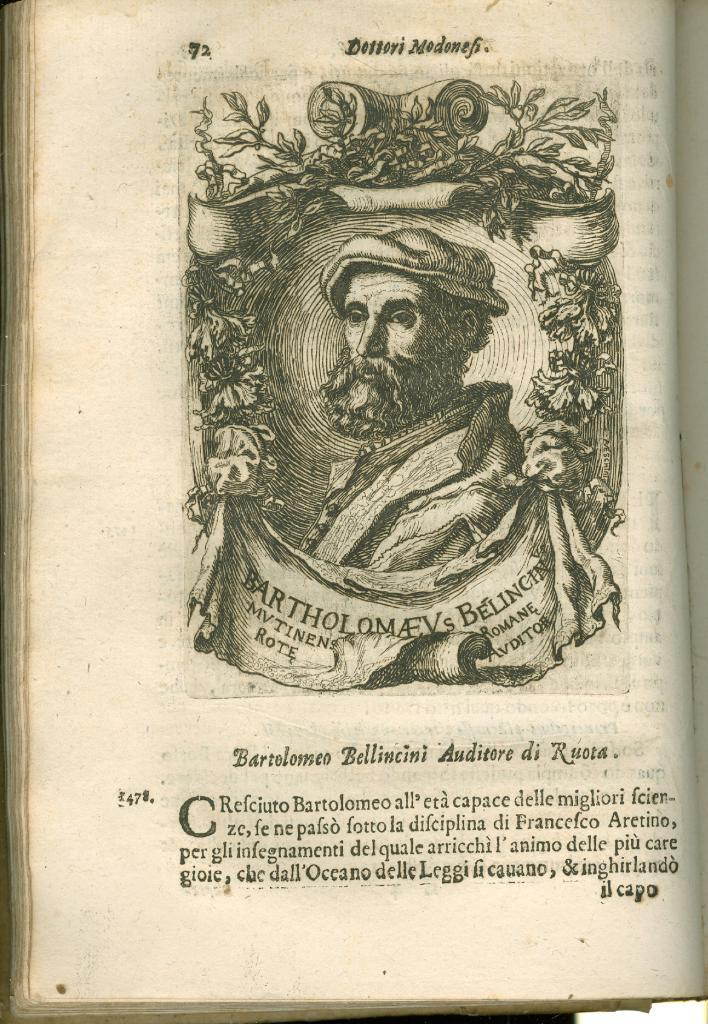What is the main object in the image? There is a book in the image. What type of content is in the book? The book contains pictures of a person. Is there any text in the book? Yes, there is text written in the book. What type of art can be seen in the town depicted in the book? There is no town depicted in the book, as it only contains pictures of a person. Who is the partner of the person in the book? There is no mention of a partner in the book, as it only contains pictures of a person. 